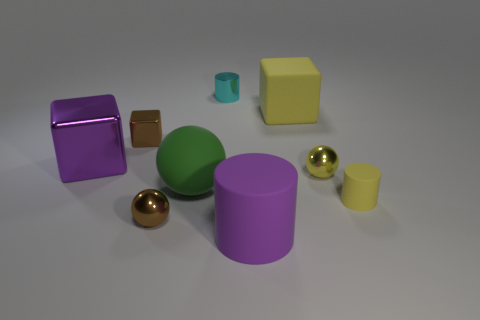What number of things are either cylinders left of the large yellow rubber block or small yellow balls?
Your answer should be very brief. 3. What is the shape of the small shiny object that is left of the brown object that is in front of the purple metallic block?
Your answer should be very brief. Cube. There is a brown cube; is its size the same as the cylinder behind the small yellow metal object?
Your answer should be compact. Yes. What material is the purple cube in front of the large yellow matte object?
Your answer should be compact. Metal. How many blocks are on the left side of the small block and to the right of the tiny metal cylinder?
Offer a terse response. 0. There is a yellow cube that is the same size as the green ball; what material is it?
Keep it short and to the point. Rubber. There is a shiny cylinder left of the purple matte cylinder; is its size the same as the cylinder to the right of the large purple cylinder?
Your answer should be very brief. Yes. Are there any large rubber objects to the left of the tiny cyan cylinder?
Keep it short and to the point. Yes. There is a big cube that is left of the purple cylinder that is in front of the shiny cylinder; what color is it?
Offer a very short reply. Purple. Is the number of big yellow matte blocks less than the number of big gray metallic cylinders?
Your answer should be very brief. No. 